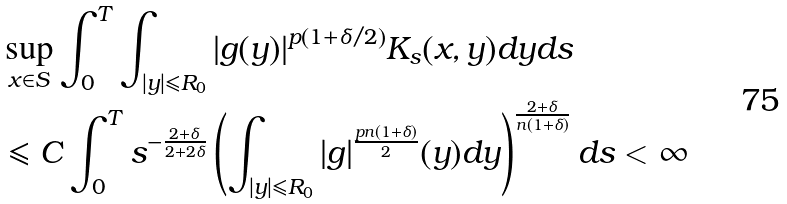<formula> <loc_0><loc_0><loc_500><loc_500>& \sup _ { x \in S } \int _ { 0 } ^ { T } \int _ { | y | \leqslant R _ { 0 } } | g ( y ) | ^ { p ( 1 + \delta / 2 ) } K _ { s } ( x , y ) d y d s \\ & \leqslant C \int _ { 0 } ^ { T } s ^ { - \frac { 2 + \delta } { 2 + 2 \delta } } \left ( \int _ { | y | \leqslant R _ { 0 } } | g | ^ { \frac { p n ( 1 + \delta ) } { 2 } } ( y ) d y \right ) ^ { \frac { 2 + \delta } { n ( 1 + \delta ) } } d s < \infty</formula> 